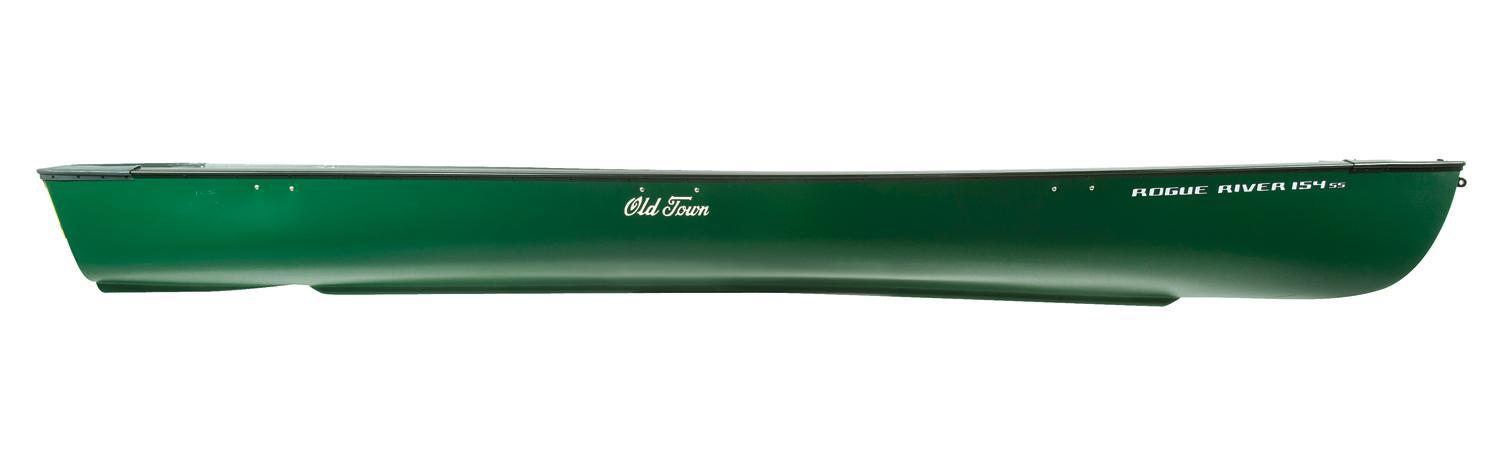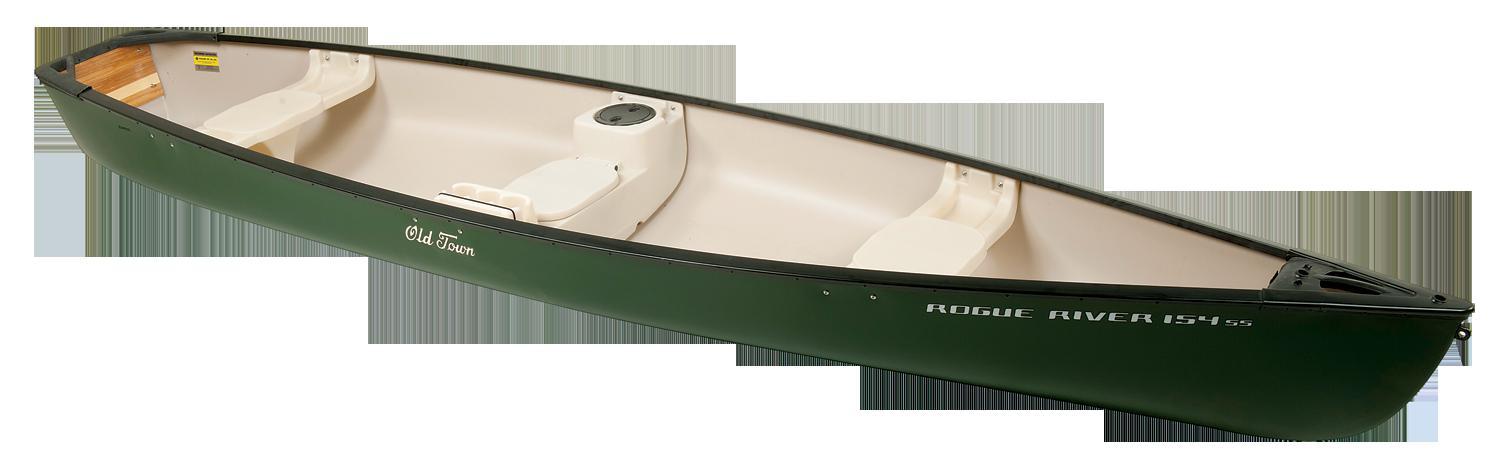The first image is the image on the left, the second image is the image on the right. Analyze the images presented: Is the assertion "At least one image shows a boat displayed horizontally in both side and aerial views." valid? Answer yes or no. No. The first image is the image on the left, the second image is the image on the right. For the images shown, is this caption "Both images show top and side angles of a green boat." true? Answer yes or no. No. 